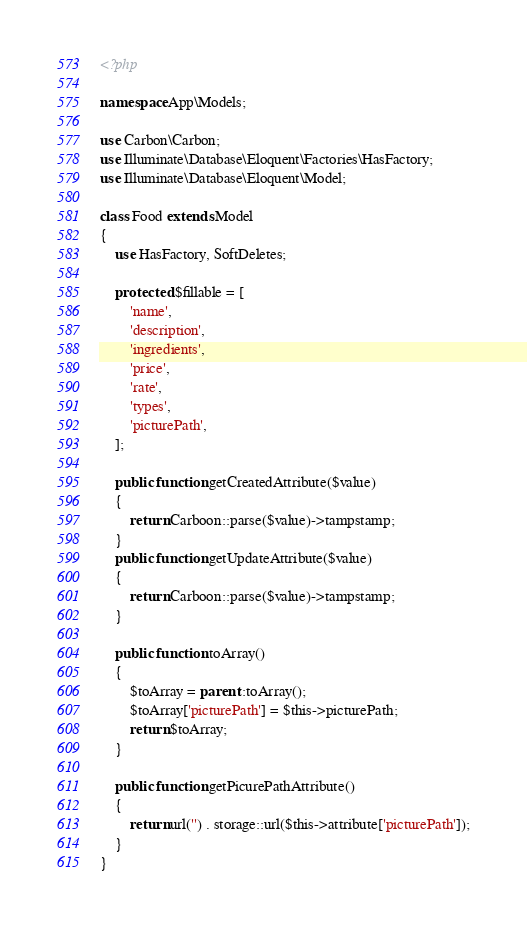<code> <loc_0><loc_0><loc_500><loc_500><_PHP_><?php

namespace App\Models;

use Carbon\Carbon;
use Illuminate\Database\Eloquent\Factories\HasFactory;
use Illuminate\Database\Eloquent\Model;

class Food extends Model
{
    use HasFactory, SoftDeletes;

    protected $fillable = [
        'name',
        'description',
        'ingredients',
        'price',
        'rate',
        'types',
        'picturePath',
    ];

    public function getCreatedAttribute($value)
    {
        return Carboon::parse($value)->tampstamp;
    }
    public function getUpdateAttribute($value)
    {
        return Carboon::parse($value)->tampstamp;
    }

    public function toArray()
    {
        $toArray = parent::toArray();
        $toArray['picturePath'] = $this->picturePath;
        return $toArray;
    }

    public function getPicurePathAttribute()
    {
        return url('') . storage::url($this->attribute['picturePath']);
    }
}
</code> 